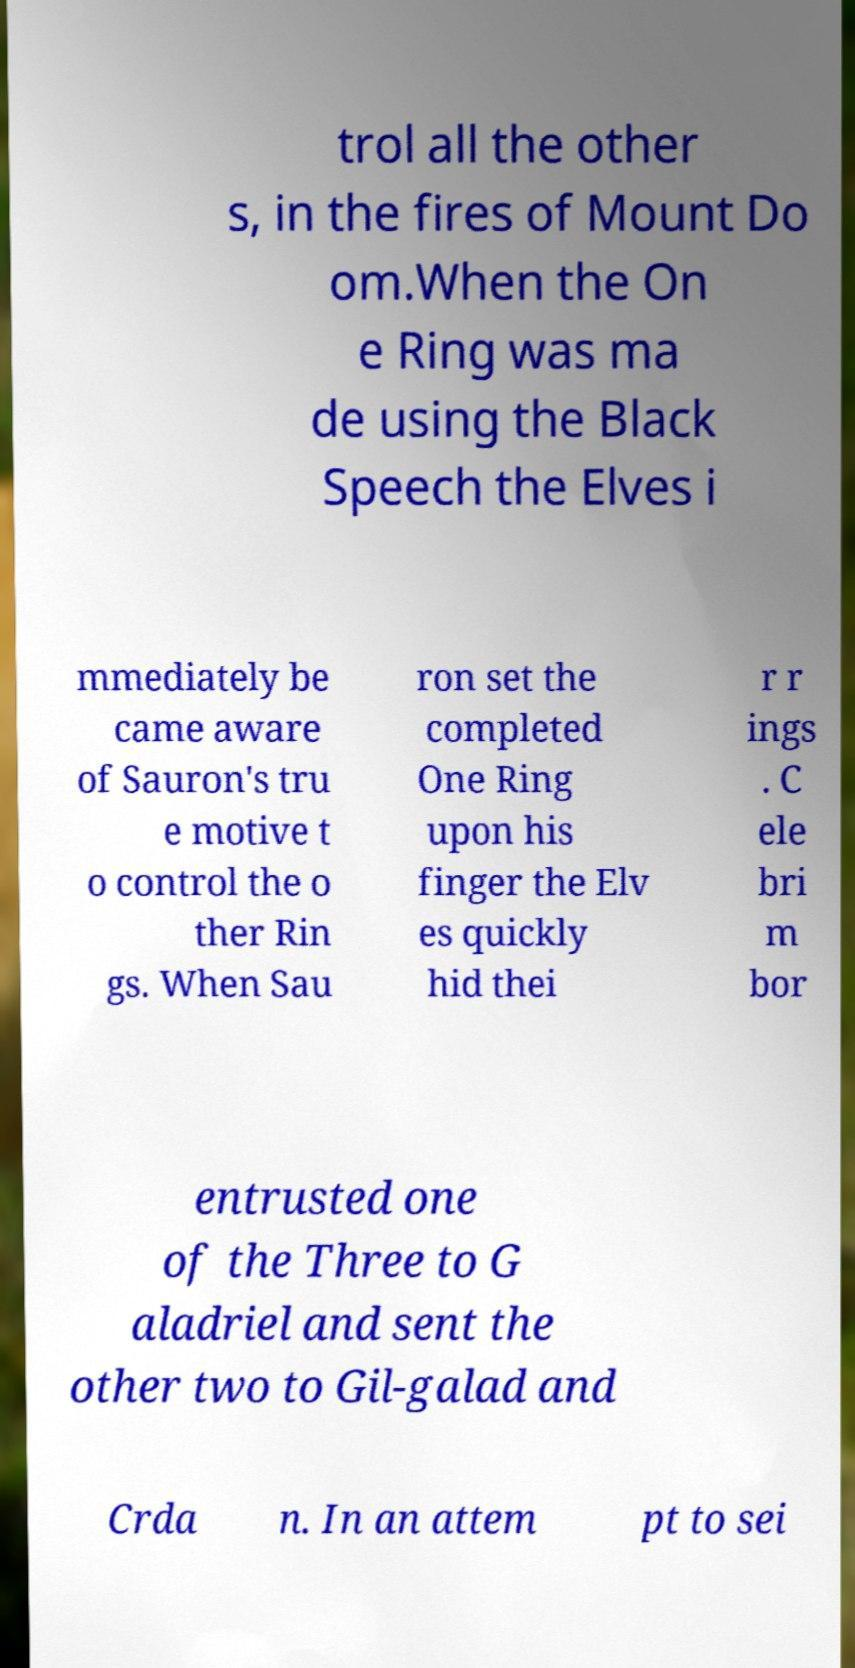I need the written content from this picture converted into text. Can you do that? trol all the other s, in the fires of Mount Do om.When the On e Ring was ma de using the Black Speech the Elves i mmediately be came aware of Sauron's tru e motive t o control the o ther Rin gs. When Sau ron set the completed One Ring upon his finger the Elv es quickly hid thei r r ings . C ele bri m bor entrusted one of the Three to G aladriel and sent the other two to Gil-galad and Crda n. In an attem pt to sei 